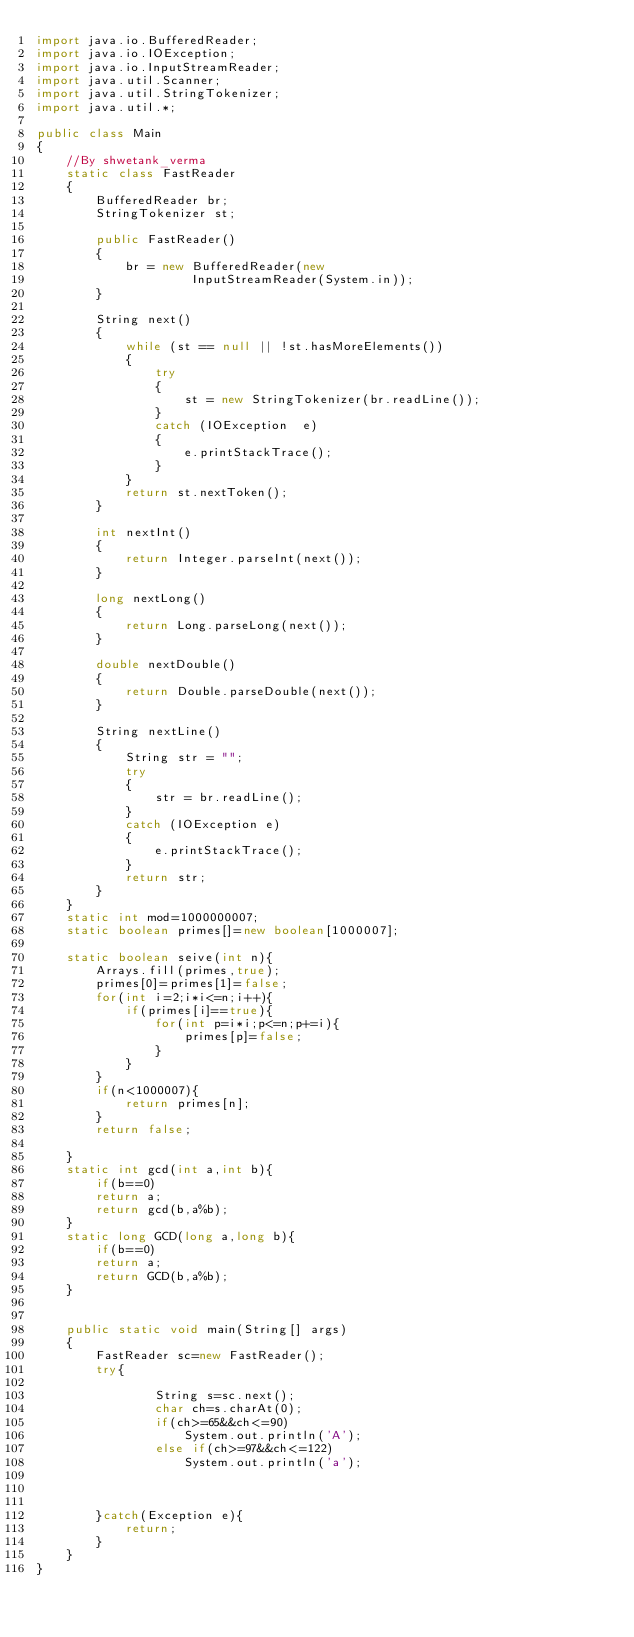Convert code to text. <code><loc_0><loc_0><loc_500><loc_500><_Java_>import java.io.BufferedReader; 
import java.io.IOException; 
import java.io.InputStreamReader; 
import java.util.Scanner; 
import java.util.StringTokenizer; 
import java.util.*;
  
public class Main
{ 
    //By shwetank_verma
    static class FastReader 
    { 
        BufferedReader br; 
        StringTokenizer st; 
  
        public FastReader() 
        { 
            br = new BufferedReader(new
                     InputStreamReader(System.in)); 
        } 
  
        String next() 
        { 
            while (st == null || !st.hasMoreElements()) 
            { 
                try
                { 
                    st = new StringTokenizer(br.readLine()); 
                } 
                catch (IOException  e) 
                { 
                    e.printStackTrace(); 
                } 
            } 
            return st.nextToken(); 
        } 
  
        int nextInt() 
        { 
            return Integer.parseInt(next()); 
        } 
  
        long nextLong() 
        { 
            return Long.parseLong(next()); 
        } 
  
        double nextDouble() 
        { 
            return Double.parseDouble(next()); 
        } 
  
        String nextLine() 
        { 
            String str = ""; 
            try
            { 
                str = br.readLine(); 
            } 
            catch (IOException e) 
            { 
                e.printStackTrace(); 
            } 
            return str; 
        } 
    } 
    static int mod=1000000007;
    static boolean primes[]=new boolean[1000007];
    
    static boolean seive(int n){
        Arrays.fill(primes,true);
        primes[0]=primes[1]=false;
        for(int i=2;i*i<=n;i++){
            if(primes[i]==true){
                for(int p=i*i;p<=n;p+=i){
                    primes[p]=false;
                }
            }
        }
        if(n<1000007){
            return primes[n];
        }
        return false;
        
    }
    static int gcd(int a,int b){
        if(b==0)
        return a;
        return gcd(b,a%b);
    }
    static long GCD(long a,long b){
        if(b==0)
        return a;
        return GCD(b,a%b);
    }
    
  
    public static void main(String[] args) 
    { 
        FastReader sc=new FastReader(); 
        try{
           
                String s=sc.next();
                char ch=s.charAt(0);
                if(ch>=65&&ch<=90)
                	System.out.println('A');
                else if(ch>=97&&ch<=122)
                	System.out.println('a');
                	
           
            
        }catch(Exception e){
            return;
        }
    } 
}
</code> 